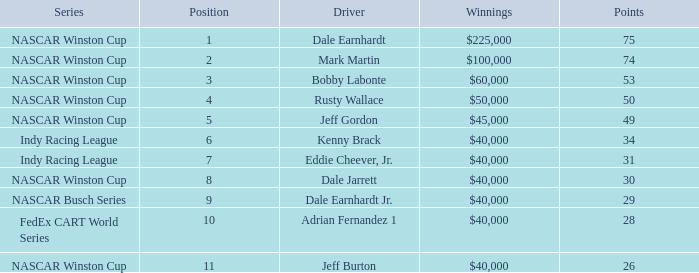In what series did Bobby Labonte drive? NASCAR Winston Cup. 